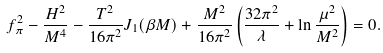<formula> <loc_0><loc_0><loc_500><loc_500>f _ { \pi } ^ { 2 } - \frac { H ^ { 2 } } { M ^ { 4 } } - \frac { T ^ { 2 } } { 1 6 \pi ^ { 2 } } J _ { 1 } ( \beta M ) + \frac { M ^ { 2 } } { 1 6 \pi ^ { 2 } } \left ( \frac { 3 2 \pi ^ { 2 } } \lambda + \ln \frac { \mu ^ { 2 } } { M ^ { 2 } } \right ) = 0 .</formula> 